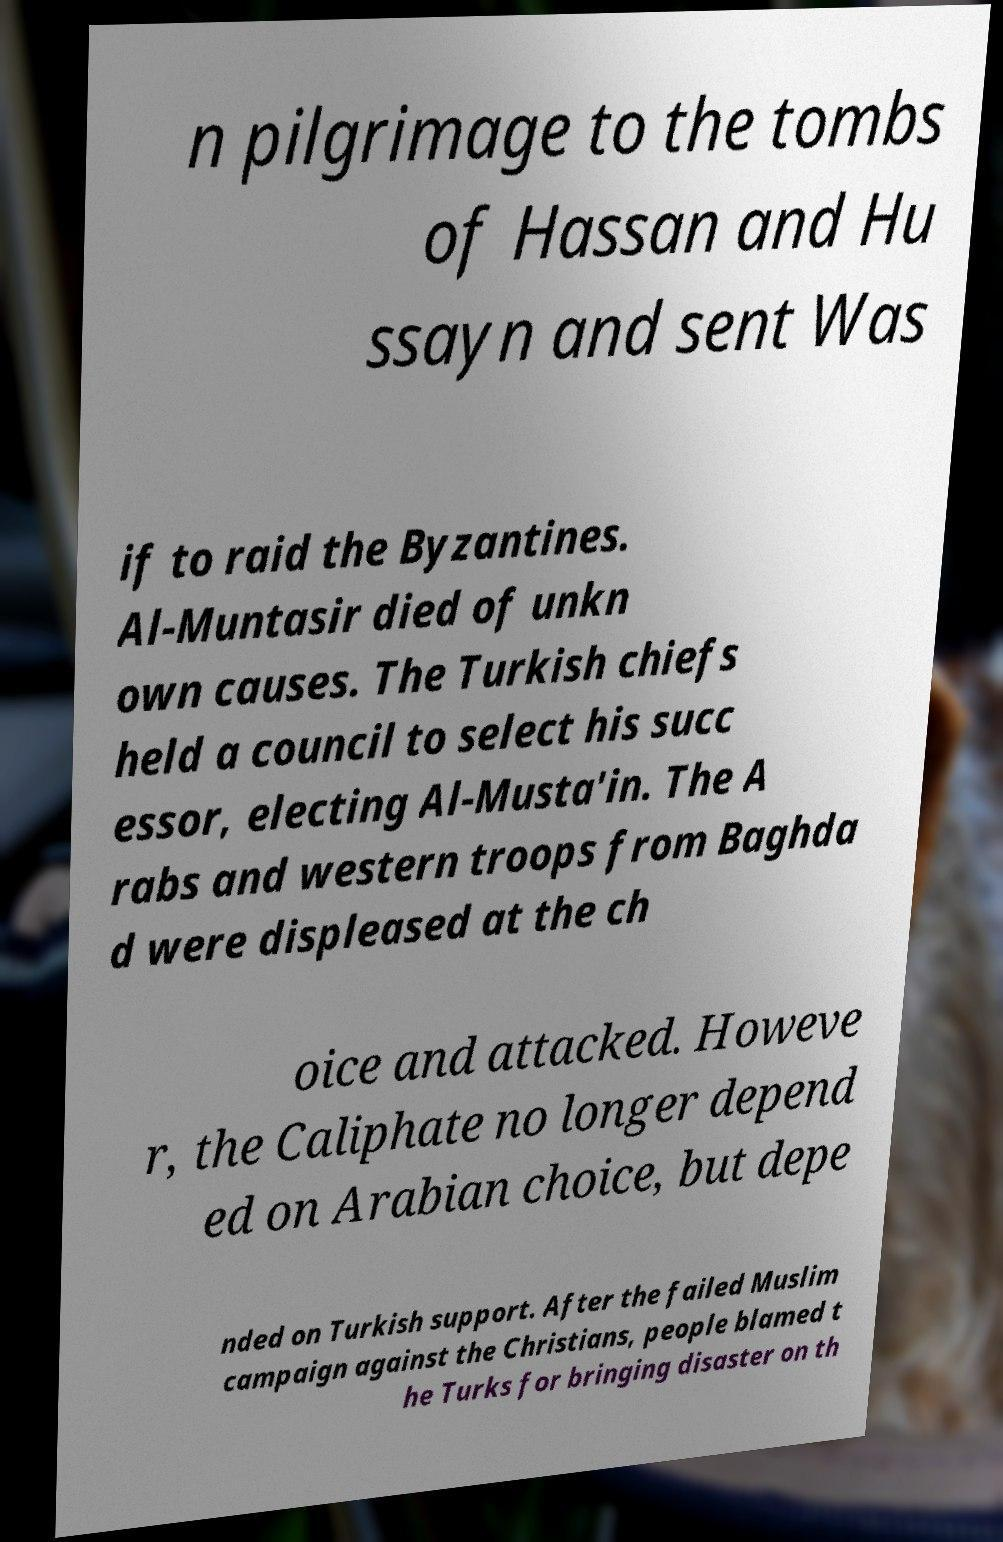I need the written content from this picture converted into text. Can you do that? n pilgrimage to the tombs of Hassan and Hu ssayn and sent Was if to raid the Byzantines. Al-Muntasir died of unkn own causes. The Turkish chiefs held a council to select his succ essor, electing Al-Musta'in. The A rabs and western troops from Baghda d were displeased at the ch oice and attacked. Howeve r, the Caliphate no longer depend ed on Arabian choice, but depe nded on Turkish support. After the failed Muslim campaign against the Christians, people blamed t he Turks for bringing disaster on th 